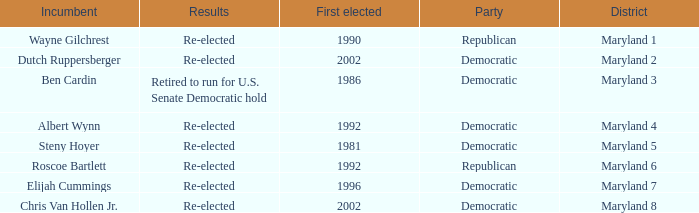What are the results of the incumbent who was first elected in 1996? Re-elected. 